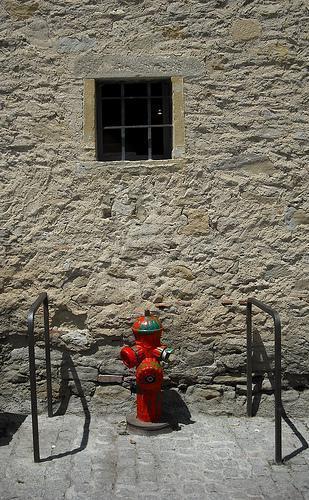How many fire hydrants are there?
Give a very brief answer. 1. 